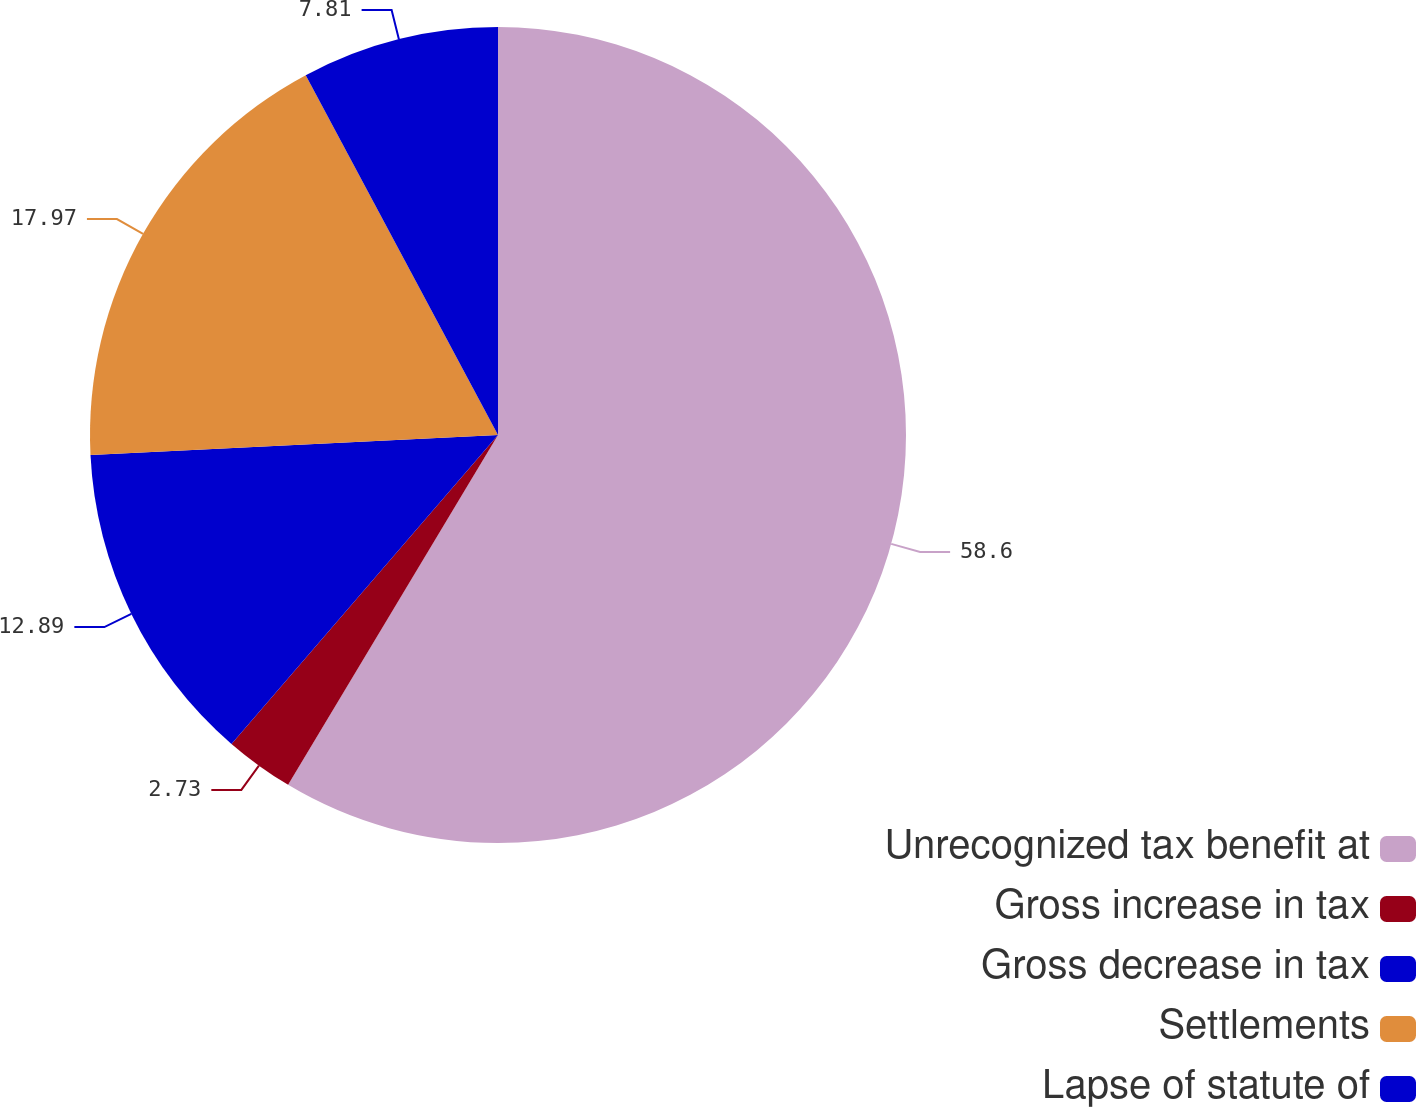<chart> <loc_0><loc_0><loc_500><loc_500><pie_chart><fcel>Unrecognized tax benefit at<fcel>Gross increase in tax<fcel>Gross decrease in tax<fcel>Settlements<fcel>Lapse of statute of<nl><fcel>58.6%<fcel>2.73%<fcel>12.89%<fcel>17.97%<fcel>7.81%<nl></chart> 